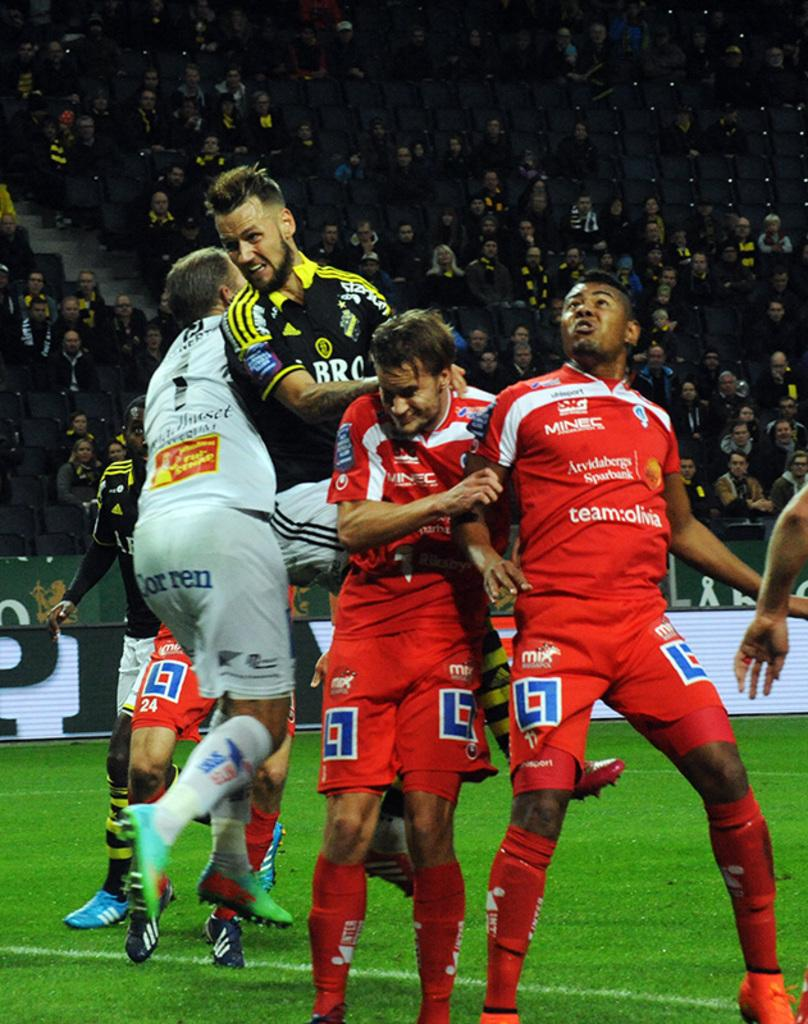<image>
Provide a brief description of the given image. some soccer players with the word team on their jerseys 